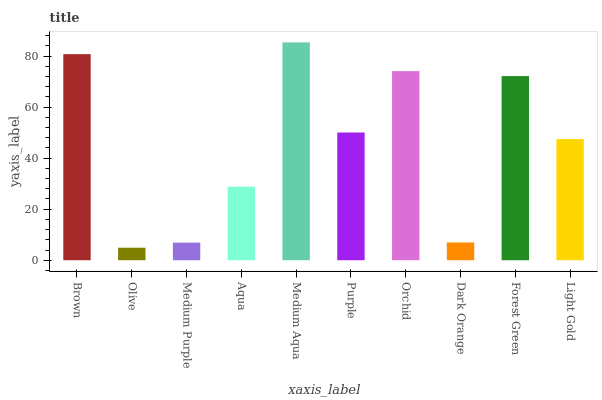Is Olive the minimum?
Answer yes or no. Yes. Is Medium Aqua the maximum?
Answer yes or no. Yes. Is Medium Purple the minimum?
Answer yes or no. No. Is Medium Purple the maximum?
Answer yes or no. No. Is Medium Purple greater than Olive?
Answer yes or no. Yes. Is Olive less than Medium Purple?
Answer yes or no. Yes. Is Olive greater than Medium Purple?
Answer yes or no. No. Is Medium Purple less than Olive?
Answer yes or no. No. Is Purple the high median?
Answer yes or no. Yes. Is Light Gold the low median?
Answer yes or no. Yes. Is Dark Orange the high median?
Answer yes or no. No. Is Olive the low median?
Answer yes or no. No. 